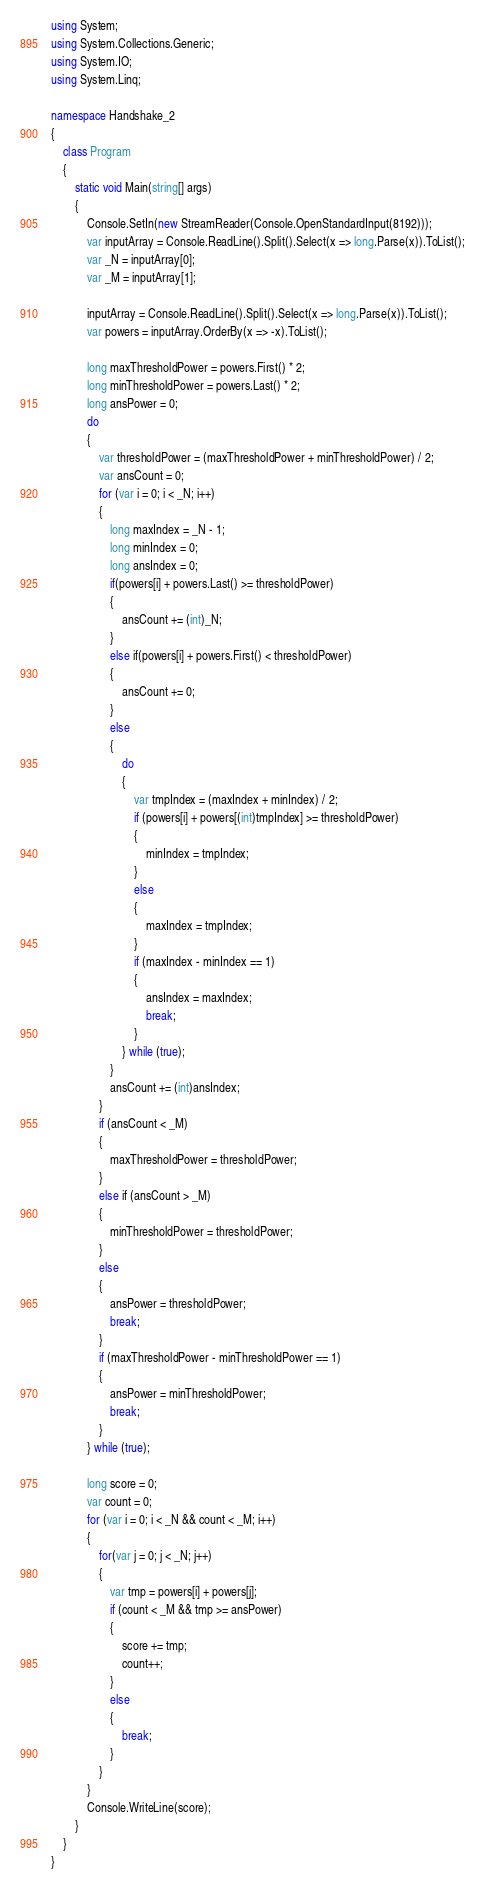<code> <loc_0><loc_0><loc_500><loc_500><_C#_>using System;
using System.Collections.Generic;
using System.IO;
using System.Linq;

namespace Handshake_2
{
    class Program
    {
        static void Main(string[] args)
        {
            Console.SetIn(new StreamReader(Console.OpenStandardInput(8192)));
            var inputArray = Console.ReadLine().Split().Select(x => long.Parse(x)).ToList();
            var _N = inputArray[0];
            var _M = inputArray[1];

            inputArray = Console.ReadLine().Split().Select(x => long.Parse(x)).ToList();
            var powers = inputArray.OrderBy(x => -x).ToList();

            long maxThresholdPower = powers.First() * 2;
            long minThresholdPower = powers.Last() * 2;
            long ansPower = 0;
            do
            {
                var thresholdPower = (maxThresholdPower + minThresholdPower) / 2;
                var ansCount = 0;
                for (var i = 0; i < _N; i++)
                {
                    long maxIndex = _N - 1;
                    long minIndex = 0;
                    long ansIndex = 0;
                    if(powers[i] + powers.Last() >= thresholdPower)
                    {
                        ansCount += (int)_N;
                    }
                    else if(powers[i] + powers.First() < thresholdPower)
                    {
                        ansCount += 0;
                    }
                    else
                    {
                        do
                        {
                            var tmpIndex = (maxIndex + minIndex) / 2;
                            if (powers[i] + powers[(int)tmpIndex] >= thresholdPower)
                            {
                                minIndex = tmpIndex;
                            }
                            else
                            {
                                maxIndex = tmpIndex;
                            }
                            if (maxIndex - minIndex == 1)
                            {
                                ansIndex = maxIndex;
                                break;
                            }
                        } while (true);
                    }
                    ansCount += (int)ansIndex;
                }
                if (ansCount < _M)
                {
                    maxThresholdPower = thresholdPower;
                }
                else if (ansCount > _M)
                {
                    minThresholdPower = thresholdPower;
                }
                else
                {
                    ansPower = thresholdPower;
                    break;
                }
                if (maxThresholdPower - minThresholdPower == 1)
                {
                    ansPower = minThresholdPower;
                    break;
                }
            } while (true);

            long score = 0;
            var count = 0;
            for (var i = 0; i < _N && count < _M; i++)
            {
                for(var j = 0; j < _N; j++)
                {
                    var tmp = powers[i] + powers[j];
                    if (count < _M && tmp >= ansPower)
                    {
                        score += tmp;
                        count++;
                    }
                    else
                    {
                        break;
                    }
                }
            }
            Console.WriteLine(score);
        }
    }
}
</code> 